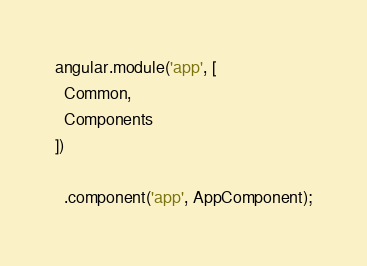Convert code to text. <code><loc_0><loc_0><loc_500><loc_500><_JavaScript_>angular.module('app', [
  Common,
  Components
])

  .component('app', AppComponent);
</code> 